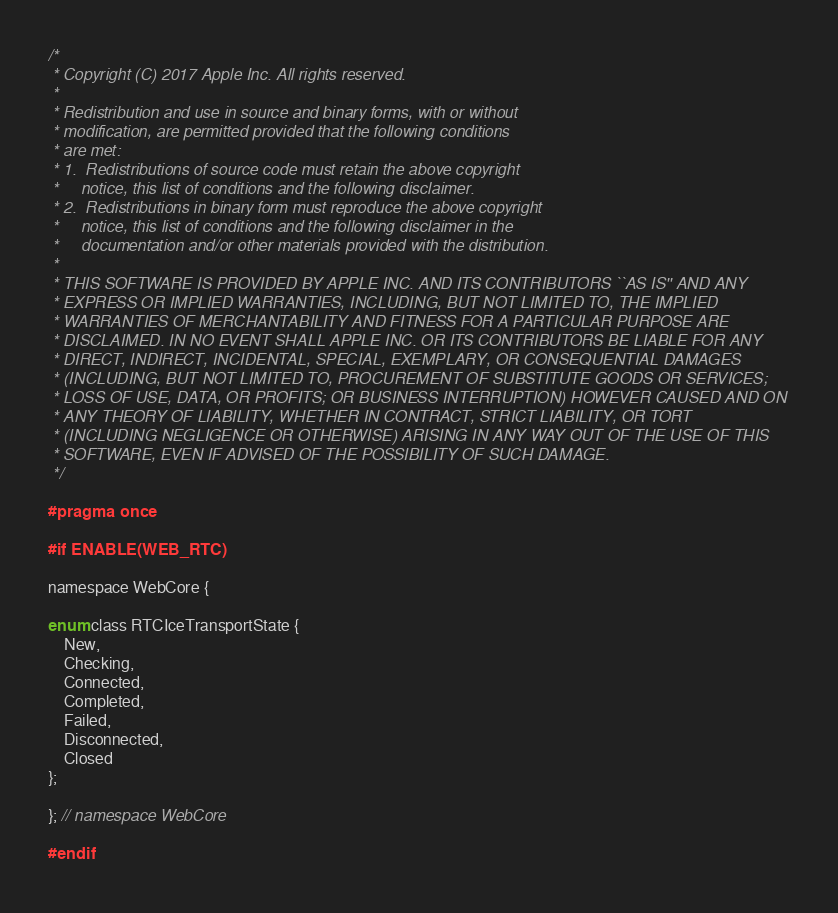Convert code to text. <code><loc_0><loc_0><loc_500><loc_500><_C_>/*
 * Copyright (C) 2017 Apple Inc. All rights reserved.
 *
 * Redistribution and use in source and binary forms, with or without
 * modification, are permitted provided that the following conditions
 * are met:
 * 1.  Redistributions of source code must retain the above copyright
 *     notice, this list of conditions and the following disclaimer.
 * 2.  Redistributions in binary form must reproduce the above copyright
 *     notice, this list of conditions and the following disclaimer in the
 *     documentation and/or other materials provided with the distribution.
 *
 * THIS SOFTWARE IS PROVIDED BY APPLE INC. AND ITS CONTRIBUTORS ``AS IS'' AND ANY
 * EXPRESS OR IMPLIED WARRANTIES, INCLUDING, BUT NOT LIMITED TO, THE IMPLIED
 * WARRANTIES OF MERCHANTABILITY AND FITNESS FOR A PARTICULAR PURPOSE ARE
 * DISCLAIMED. IN NO EVENT SHALL APPLE INC. OR ITS CONTRIBUTORS BE LIABLE FOR ANY
 * DIRECT, INDIRECT, INCIDENTAL, SPECIAL, EXEMPLARY, OR CONSEQUENTIAL DAMAGES
 * (INCLUDING, BUT NOT LIMITED TO, PROCUREMENT OF SUBSTITUTE GOODS OR SERVICES;
 * LOSS OF USE, DATA, OR PROFITS; OR BUSINESS INTERRUPTION) HOWEVER CAUSED AND ON
 * ANY THEORY OF LIABILITY, WHETHER IN CONTRACT, STRICT LIABILITY, OR TORT
 * (INCLUDING NEGLIGENCE OR OTHERWISE) ARISING IN ANY WAY OUT OF THE USE OF THIS
 * SOFTWARE, EVEN IF ADVISED OF THE POSSIBILITY OF SUCH DAMAGE.
 */

#pragma once

#if ENABLE(WEB_RTC)

namespace WebCore {

enum class RTCIceTransportState {
    New,
    Checking,
    Connected,
    Completed,
    Failed,
    Disconnected,
    Closed
};

}; // namespace WebCore

#endif
</code> 